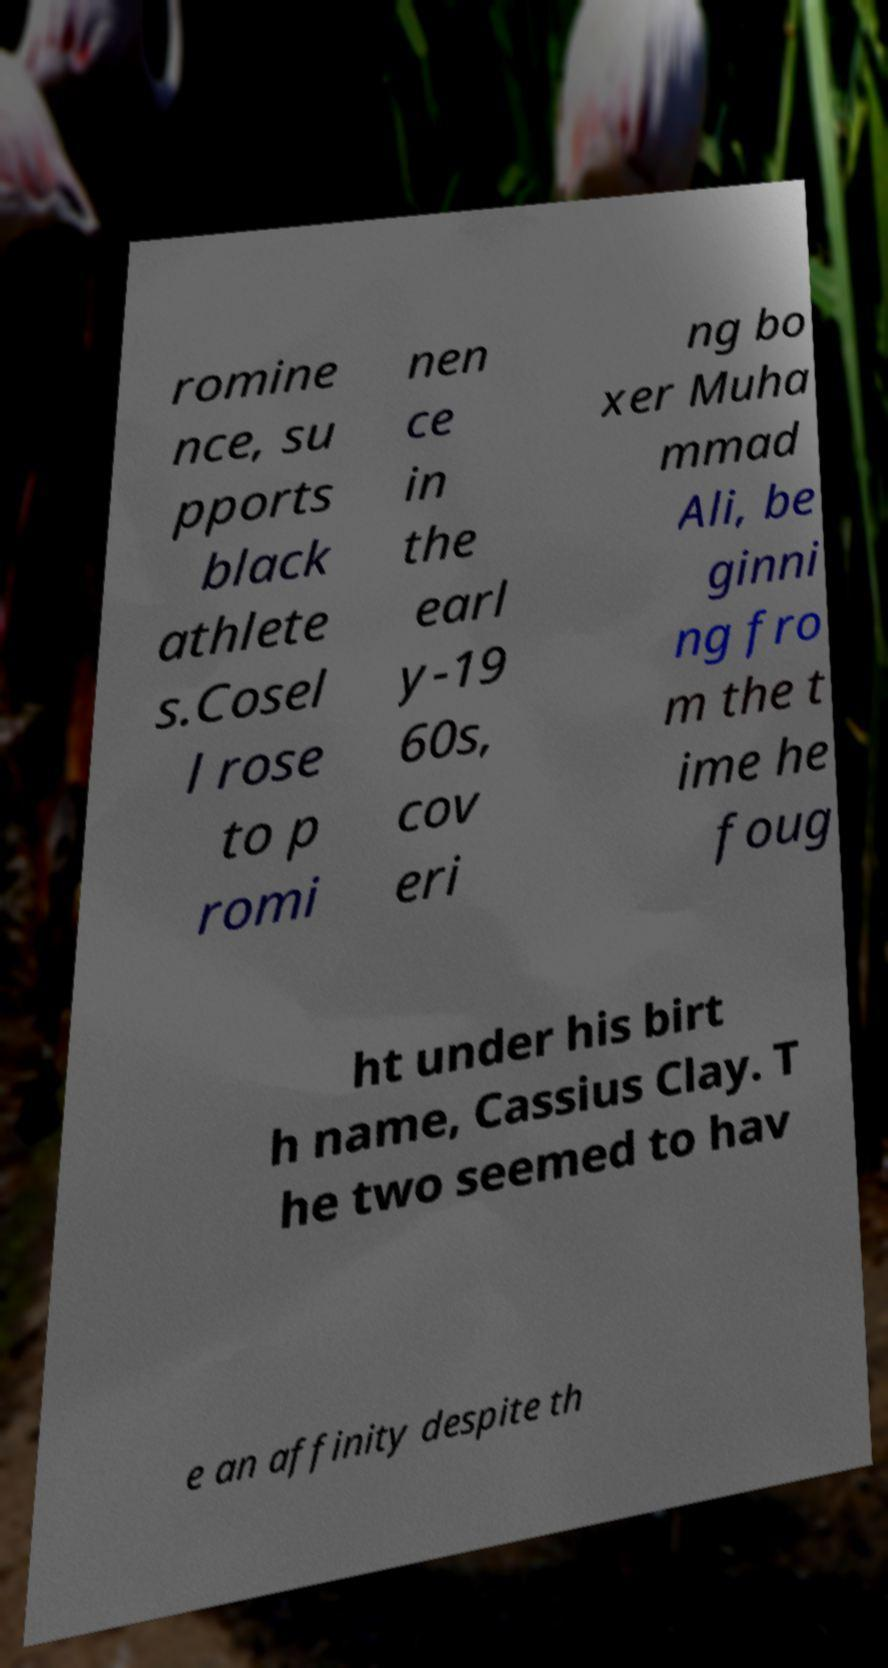Could you extract and type out the text from this image? romine nce, su pports black athlete s.Cosel l rose to p romi nen ce in the earl y-19 60s, cov eri ng bo xer Muha mmad Ali, be ginni ng fro m the t ime he foug ht under his birt h name, Cassius Clay. T he two seemed to hav e an affinity despite th 